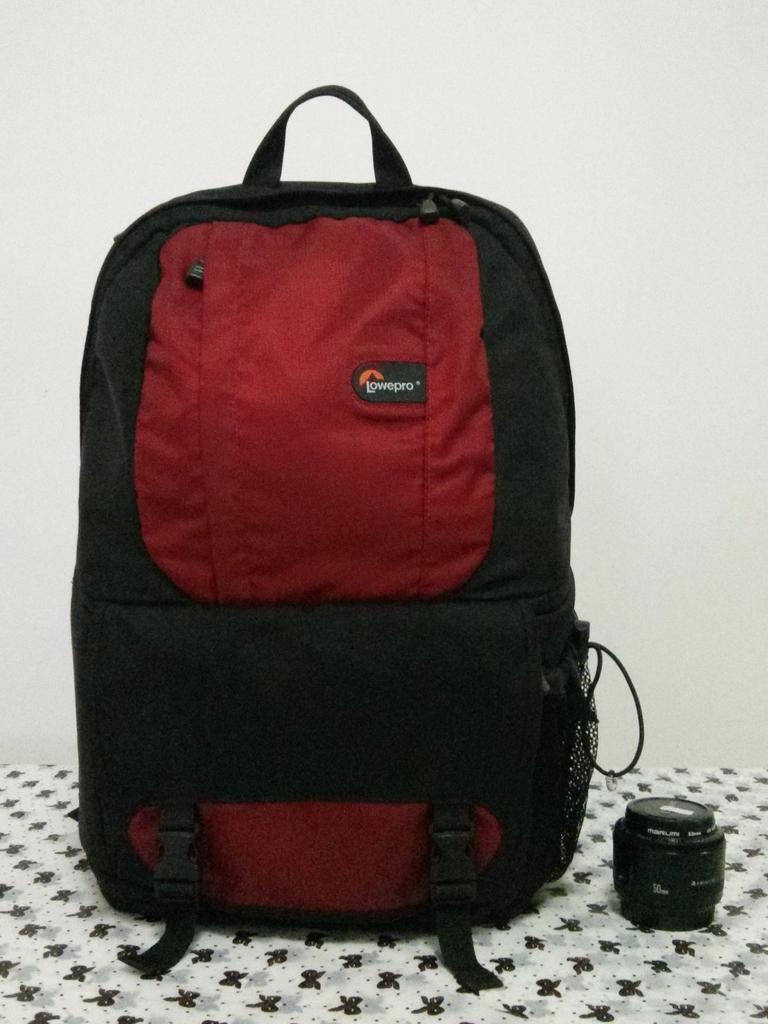What type of bag is visible in the image? There is a red color backpack in the image. What can be seen on the right side of the image? There is a lens on the right side of the image. What type of mask is being worn by the person in the image? There is no person or mask present in the image; it only features a red color backpack and a lens. 